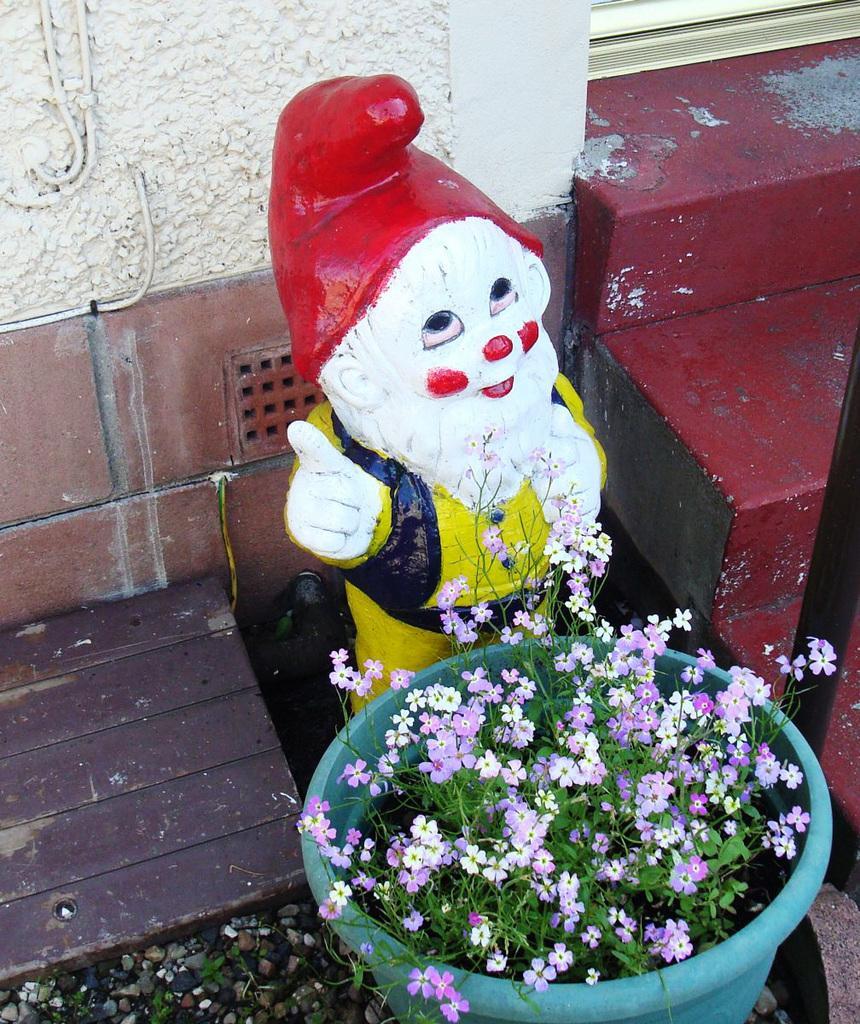In one or two sentences, can you explain what this image depicts? In this picture I can see a plant with flowers in a flowerpot, there are stars, there is a toy, and in the background there is a wall. 